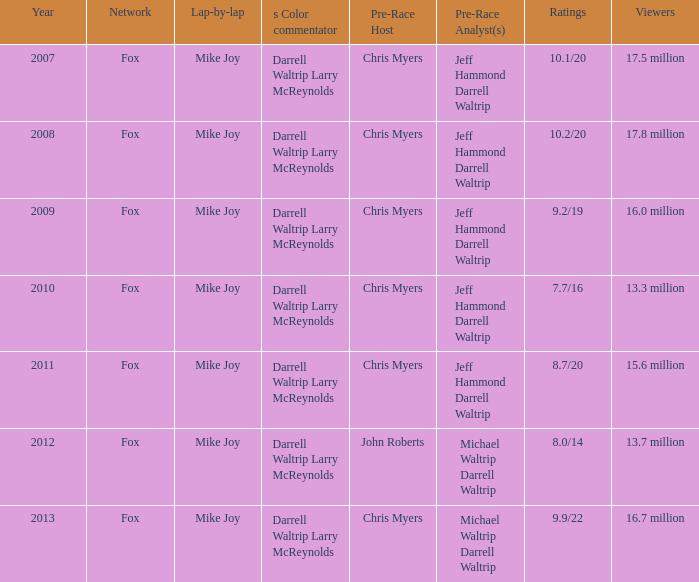Which channel has a viewership of 17.5 million people? Fox. 